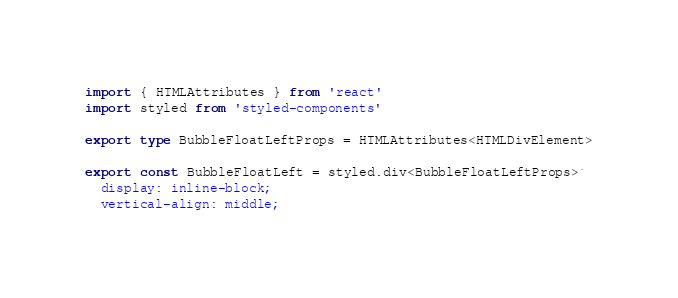Convert code to text. <code><loc_0><loc_0><loc_500><loc_500><_TypeScript_>import { HTMLAttributes } from 'react'
import styled from 'styled-components'

export type BubbleFloatLeftProps = HTMLAttributes<HTMLDivElement>

export const BubbleFloatLeft = styled.div<BubbleFloatLeftProps>`
  display: inline-block;
  vertical-align: middle;</code> 